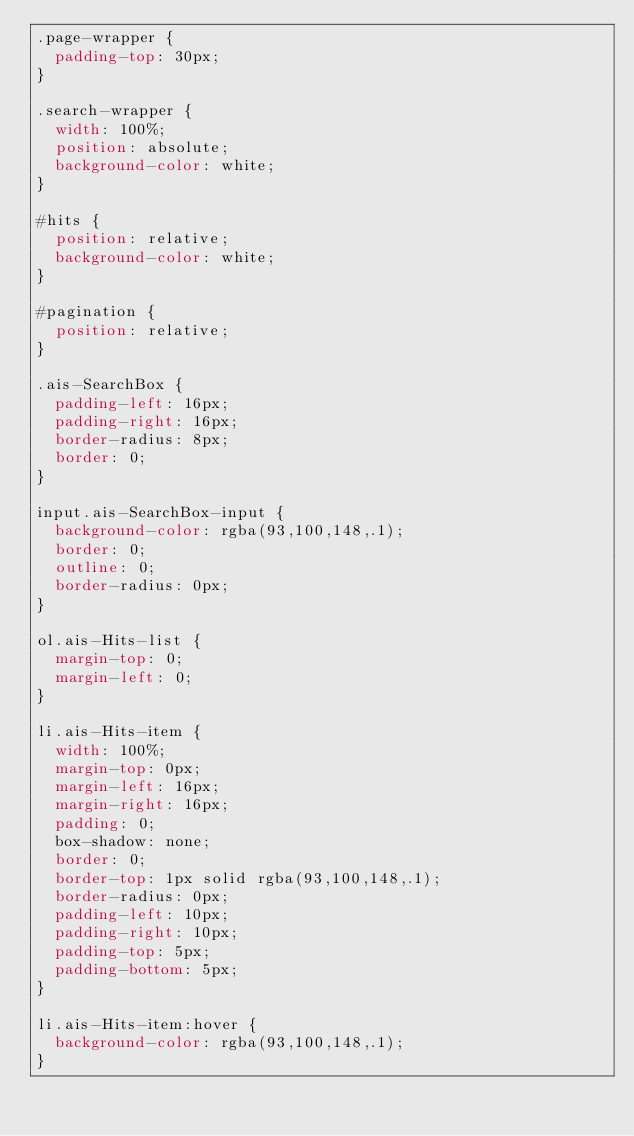Convert code to text. <code><loc_0><loc_0><loc_500><loc_500><_CSS_>.page-wrapper {
  padding-top: 30px;
}

.search-wrapper {
  width: 100%;
  position: absolute;
  background-color: white;
}

#hits {
  position: relative;
  background-color: white;
}

#pagination {
  position: relative;
}

.ais-SearchBox {
  padding-left: 16px;
  padding-right: 16px;
  border-radius: 8px;
  border: 0;
}

input.ais-SearchBox-input {
  background-color: rgba(93,100,148,.1);
  border: 0;
  outline: 0;
  border-radius: 0px;
}

ol.ais-Hits-list {
  margin-top: 0;
  margin-left: 0;
}

li.ais-Hits-item {
  width: 100%;
  margin-top: 0px;
  margin-left: 16px;
  margin-right: 16px;
  padding: 0;
  box-shadow: none;
  border: 0;
  border-top: 1px solid rgba(93,100,148,.1);
  border-radius: 0px;
  padding-left: 10px;
  padding-right: 10px;
  padding-top: 5px;
  padding-bottom: 5px;
}

li.ais-Hits-item:hover {
  background-color: rgba(93,100,148,.1);
}
</code> 